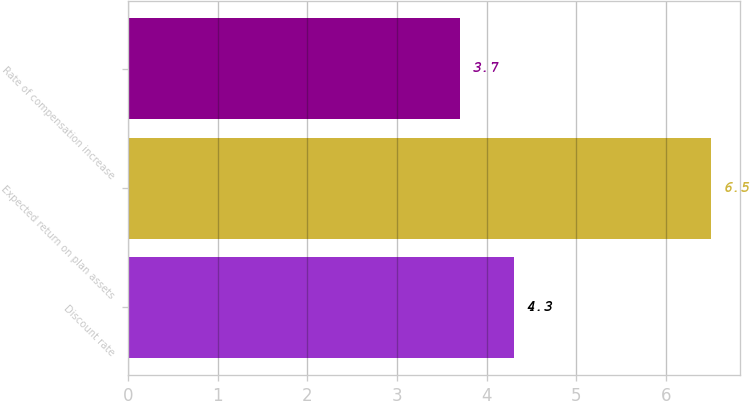Convert chart. <chart><loc_0><loc_0><loc_500><loc_500><bar_chart><fcel>Discount rate<fcel>Expected return on plan assets<fcel>Rate of compensation increase<nl><fcel>4.3<fcel>6.5<fcel>3.7<nl></chart> 